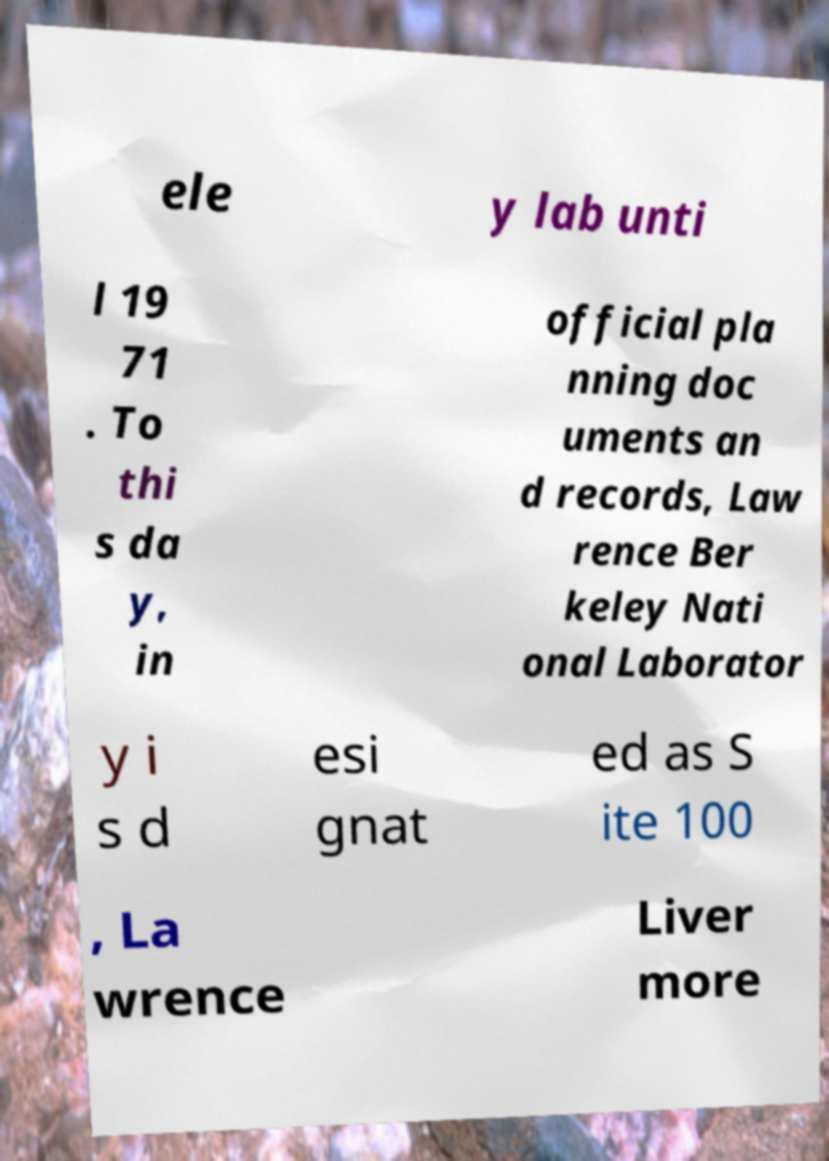Please identify and transcribe the text found in this image. ele y lab unti l 19 71 . To thi s da y, in official pla nning doc uments an d records, Law rence Ber keley Nati onal Laborator y i s d esi gnat ed as S ite 100 , La wrence Liver more 